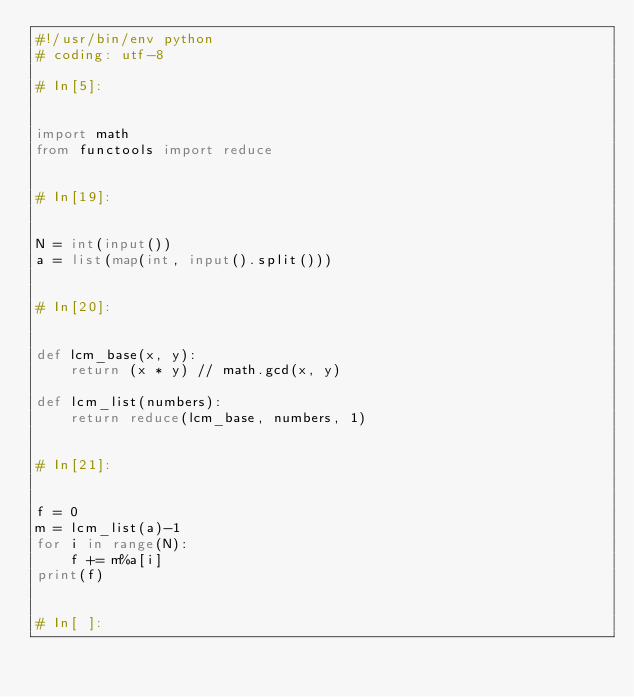<code> <loc_0><loc_0><loc_500><loc_500><_Python_>#!/usr/bin/env python
# coding: utf-8

# In[5]:


import math
from functools import reduce


# In[19]:


N = int(input())
a = list(map(int, input().split()))


# In[20]:


def lcm_base(x, y):
    return (x * y) // math.gcd(x, y)

def lcm_list(numbers):
    return reduce(lcm_base, numbers, 1)


# In[21]:


f = 0
m = lcm_list(a)-1
for i in range(N):
    f += m%a[i]
print(f)


# In[ ]:




</code> 